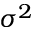<formula> <loc_0><loc_0><loc_500><loc_500>\sigma ^ { 2 }</formula> 